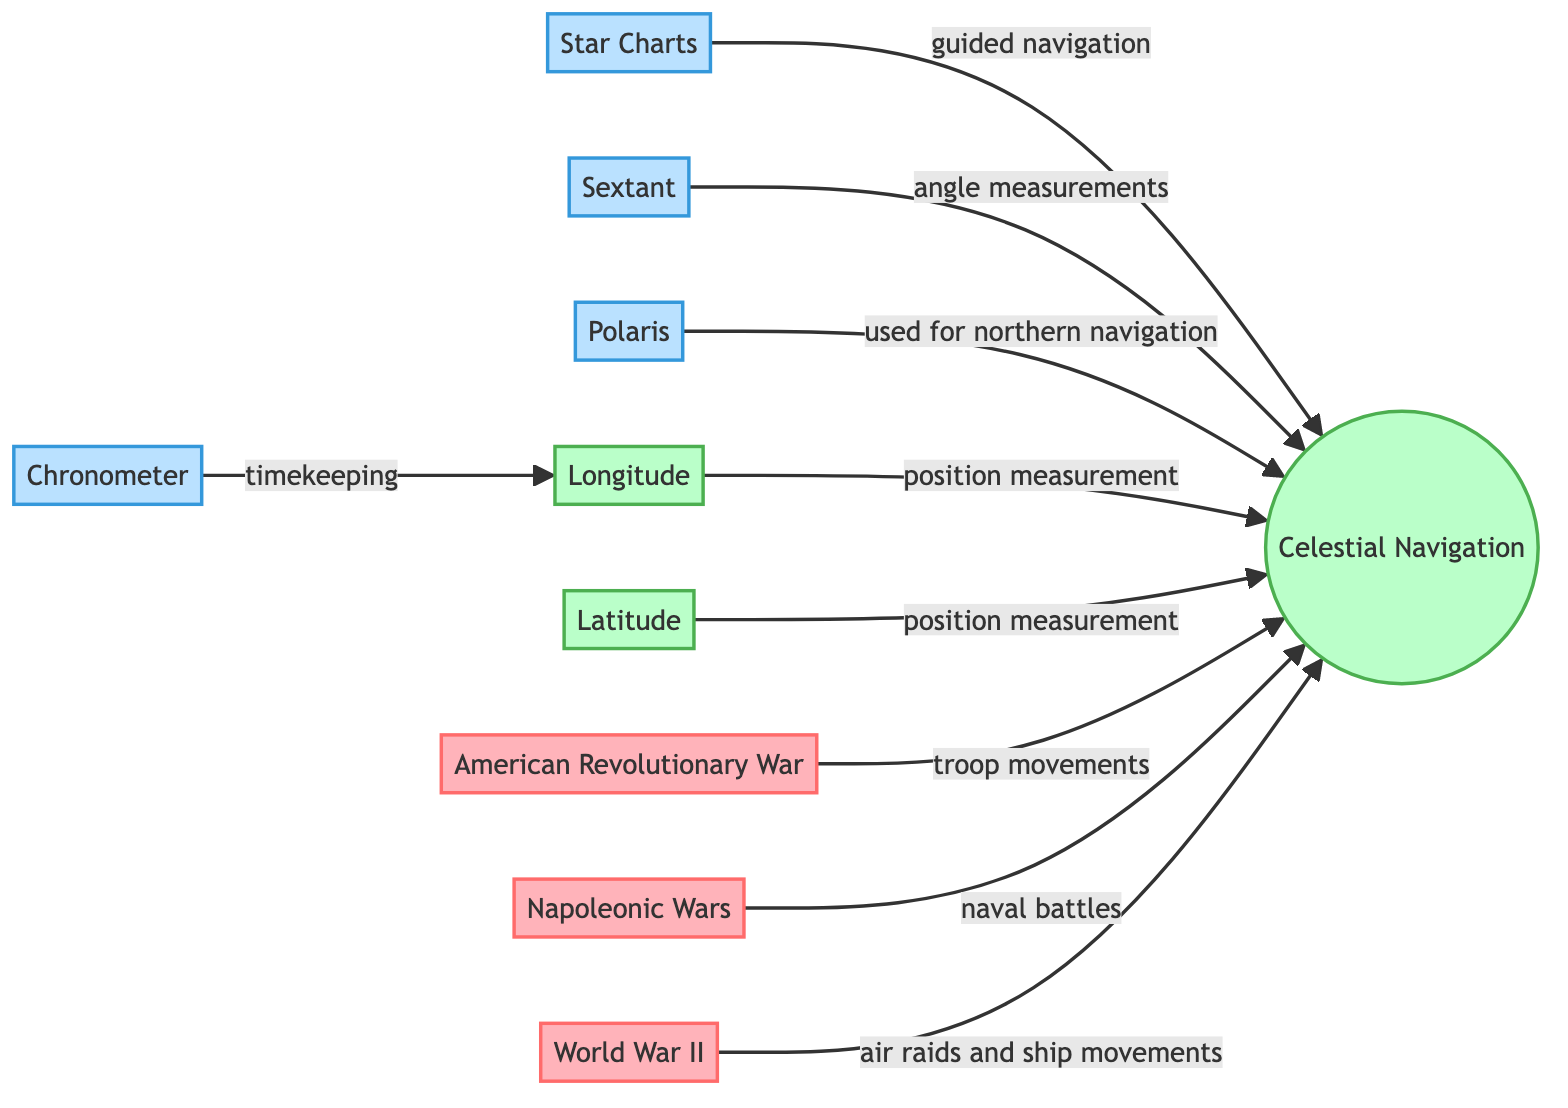What is the title of the main navigation method depicted? The main navigation method depicted in the diagram is named "Celestial Navigation," as indicated at the center of the diagram.
Answer: Celestial Navigation Which tool is connected to the measurement of angles? The tool connected to the measurement of angles is the "Sextant," which is specifically noted for its role in celestial navigation by determining angles.
Answer: Sextant How many wars are represented in the diagram? There are three wars represented in the diagram: "American Revolutionary War," "Napoleonic Wars," and "World War II."
Answer: 3 What celestial body is mentioned for northern navigation? The celestial body mentioned for northern navigation is "Polaris," which is indicated as a key reference point in celestial navigation.
Answer: Polaris Which war is associated with naval battles? The war that is associated with naval battles is the "Napoleonic Wars," as described in the relationship shown in the diagram.
Answer: Napoleonic Wars What advancement is indicated for timekeeping associated with longitude? The advancement indicated for timekeeping associated with longitude is the "Chronometer," which is essential for accurate timekeeping in navigation.
Answer: Chronometer What is the purpose of star charts in this context? The purpose of star charts in this context is "guided navigation," as they provide essential information for celestial navigation.
Answer: guided navigation In which war did celestial navigation aid troop movements? Celestial navigation aided troop movements in the "American Revolutionary War," as depicted in the diagram.
Answer: American Revolutionary War Which two measurements are connected to celestial navigation? The two measurements connected to celestial navigation are "Longitude" and "Latitude," both crucial for determining a ship's or aircraft's position.
Answer: Longitude and Latitude What type of diagram is used to illustrate the role of astronomy? The type of diagram used to illustrate the role of astronomy is an "Astronomy Diagram," highlighting the connections between celestial navigation and military strategies.
Answer: Astronomy Diagram 